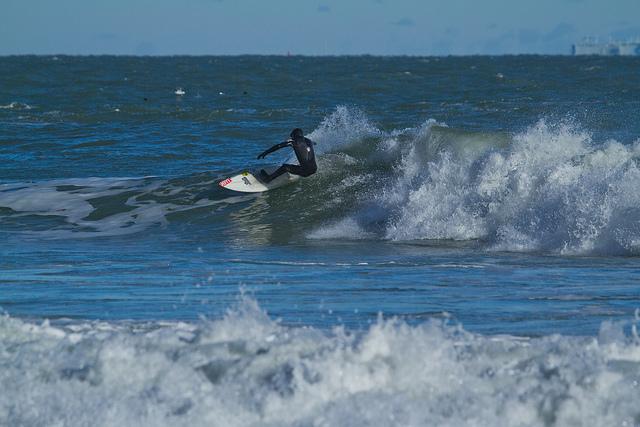What is in the background?
Be succinct. Water. IS the water cold?
Write a very short answer. Yes. How many people are surfing?
Give a very brief answer. 1. Is anyone surfing?
Write a very short answer. Yes. Are the waves foamy?
Short answer required. Yes. What is this person doing?
Concise answer only. Surfing. Is the man falling backwards or forwards?
Keep it brief. Backwards. What color is the photo?
Concise answer only. Blue. 